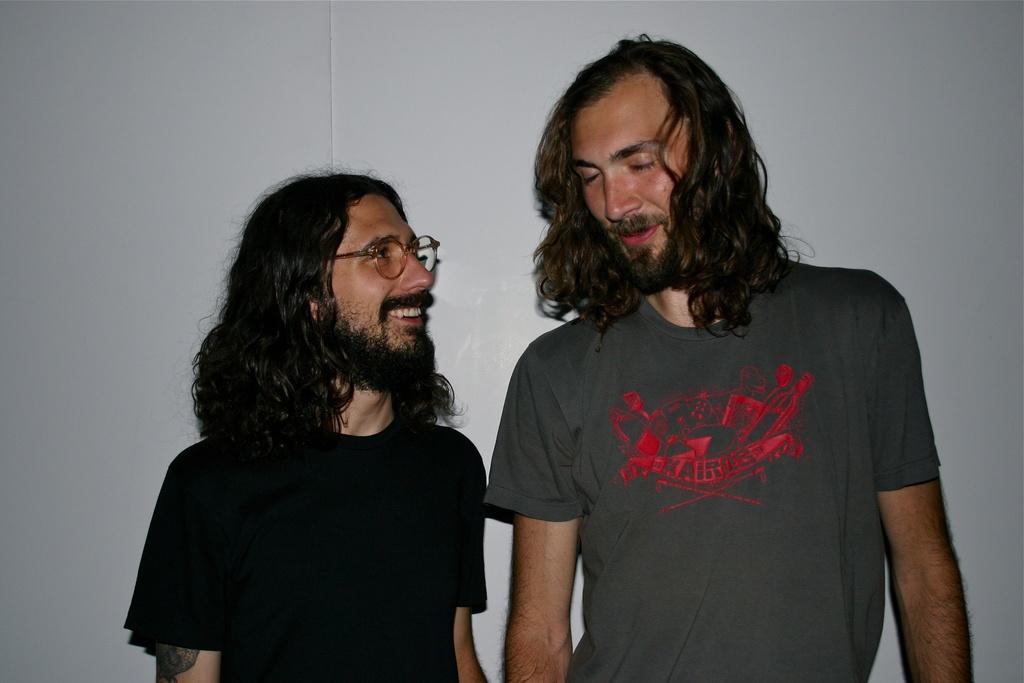How would you summarize this image in a sentence or two? This image consists of two persons. They are wearing T-shirts. Both are having long hair. In the background, there is a wall in white color. 